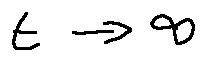<formula> <loc_0><loc_0><loc_500><loc_500>t \rightarrow \infty</formula> 